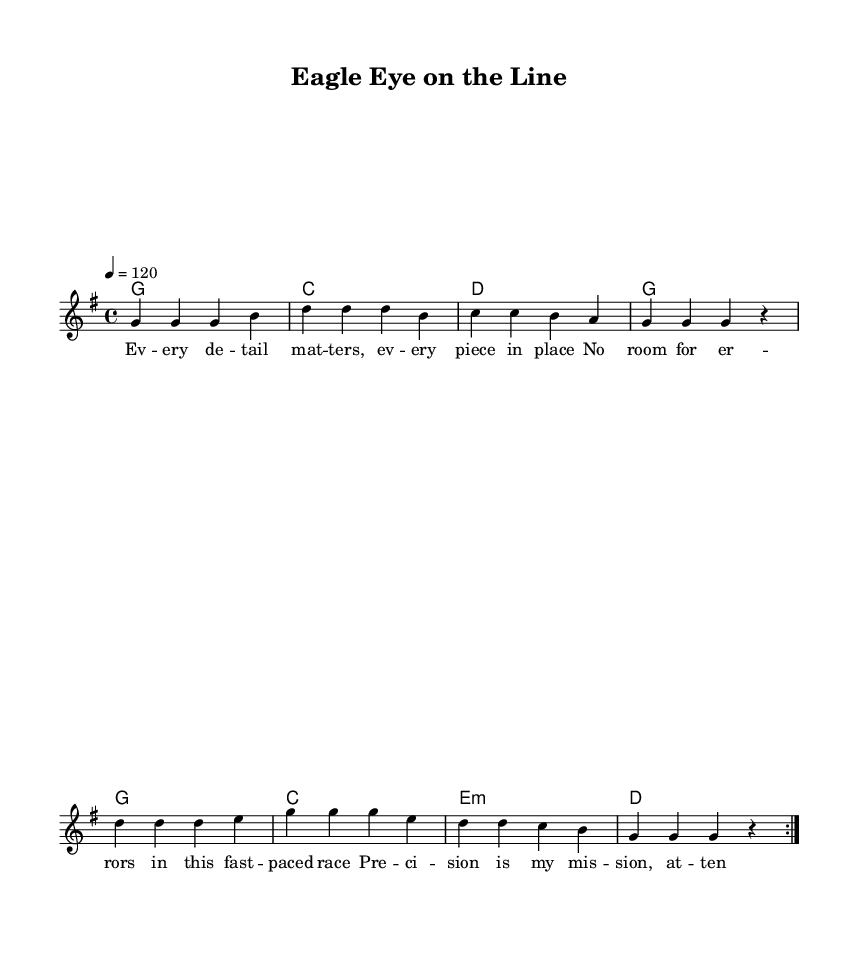What is the key signature of this music? The key signature is G major, which contains one sharp (F#). This can be identified by observing the key signature indicated at the beginning of the staff.
Answer: G major What is the time signature of this music? The time signature is 4/4, which means there are four beats in each measure, and the quarter note gets one beat. This is shown at the beginning of the piece.
Answer: 4/4 What is the tempo marking for this piece? The tempo marking is quarter note = 120, indicating the speed at which the piece should be played. This can be found near the beginning of the score.
Answer: 120 How many times is the melody repeated? The melody is repeated two times, as noted by the "volta" marking that indicates a repeat section. This shows that the melody section is structured to be played twice.
Answer: 2 What is the primary theme of the lyrics? The primary theme of the lyrics revolves around precision and attention to detail, emphasizing the importance of every little element in achieving quality. This can be deduced by reading the lyrics in the context of the song's overall message.
Answer: Precision Which chord appears most frequently in the harmony section? The chord G appears most frequently in the harmony section, as it is the first chord listed and is repeated multiple times throughout the piece. Noticing the repetition of the chord can help identify its predominance.
Answer: G What genre does this song belong to? This song belongs to the country rock genre, characterized by its fusion of country music elements with rock influences, as indicated by both the musical style and the lyrical content.
Answer: Country rock 